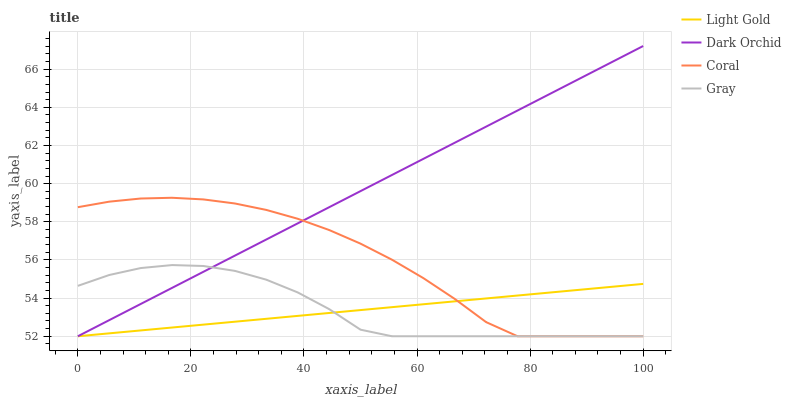Does Light Gold have the minimum area under the curve?
Answer yes or no. Yes. Does Dark Orchid have the maximum area under the curve?
Answer yes or no. Yes. Does Coral have the minimum area under the curve?
Answer yes or no. No. Does Coral have the maximum area under the curve?
Answer yes or no. No. Is Light Gold the smoothest?
Answer yes or no. Yes. Is Gray the roughest?
Answer yes or no. Yes. Is Coral the smoothest?
Answer yes or no. No. Is Coral the roughest?
Answer yes or no. No. Does Gray have the lowest value?
Answer yes or no. Yes. Does Dark Orchid have the highest value?
Answer yes or no. Yes. Does Coral have the highest value?
Answer yes or no. No. Does Coral intersect Gray?
Answer yes or no. Yes. Is Coral less than Gray?
Answer yes or no. No. Is Coral greater than Gray?
Answer yes or no. No. 